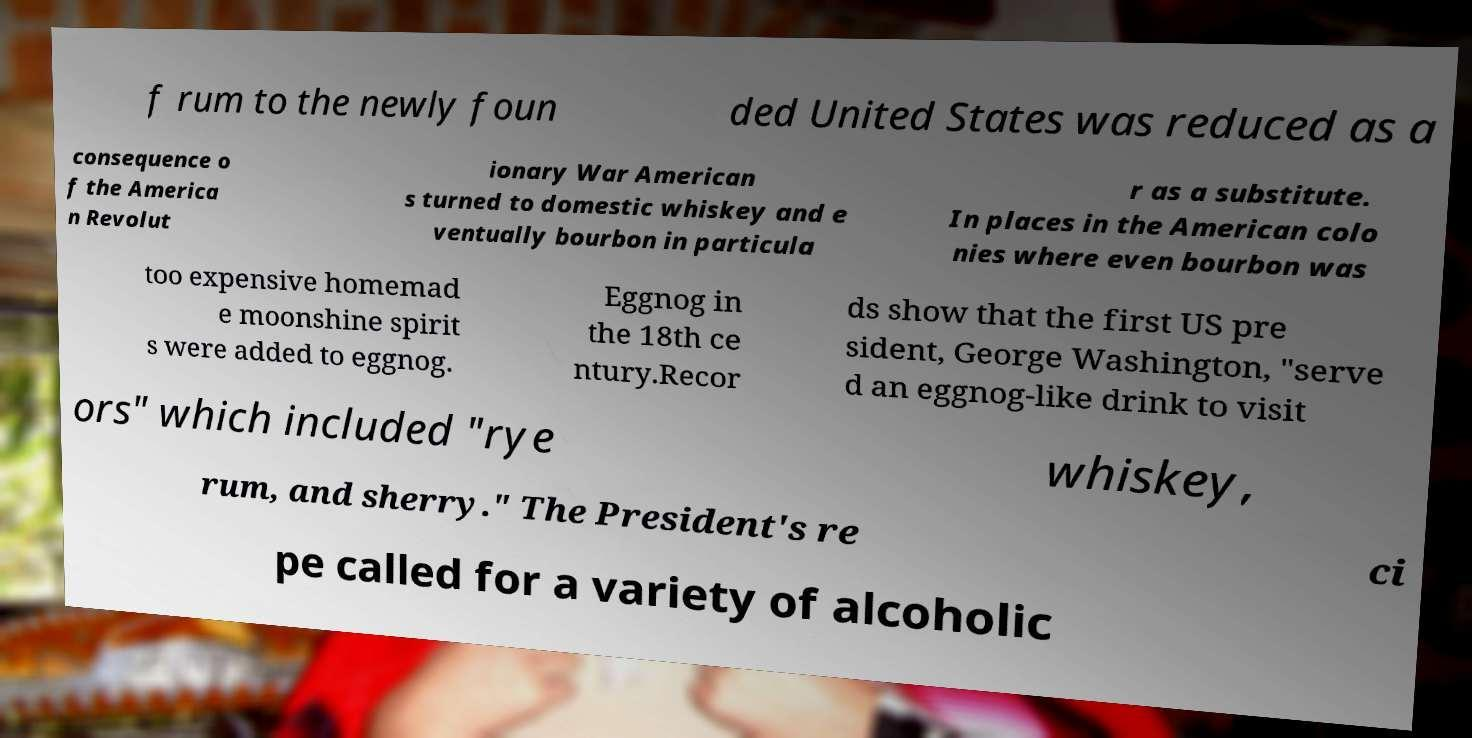Can you accurately transcribe the text from the provided image for me? f rum to the newly foun ded United States was reduced as a consequence o f the America n Revolut ionary War American s turned to domestic whiskey and e ventually bourbon in particula r as a substitute. In places in the American colo nies where even bourbon was too expensive homemad e moonshine spirit s were added to eggnog. Eggnog in the 18th ce ntury.Recor ds show that the first US pre sident, George Washington, "serve d an eggnog-like drink to visit ors" which included "rye whiskey, rum, and sherry." The President's re ci pe called for a variety of alcoholic 